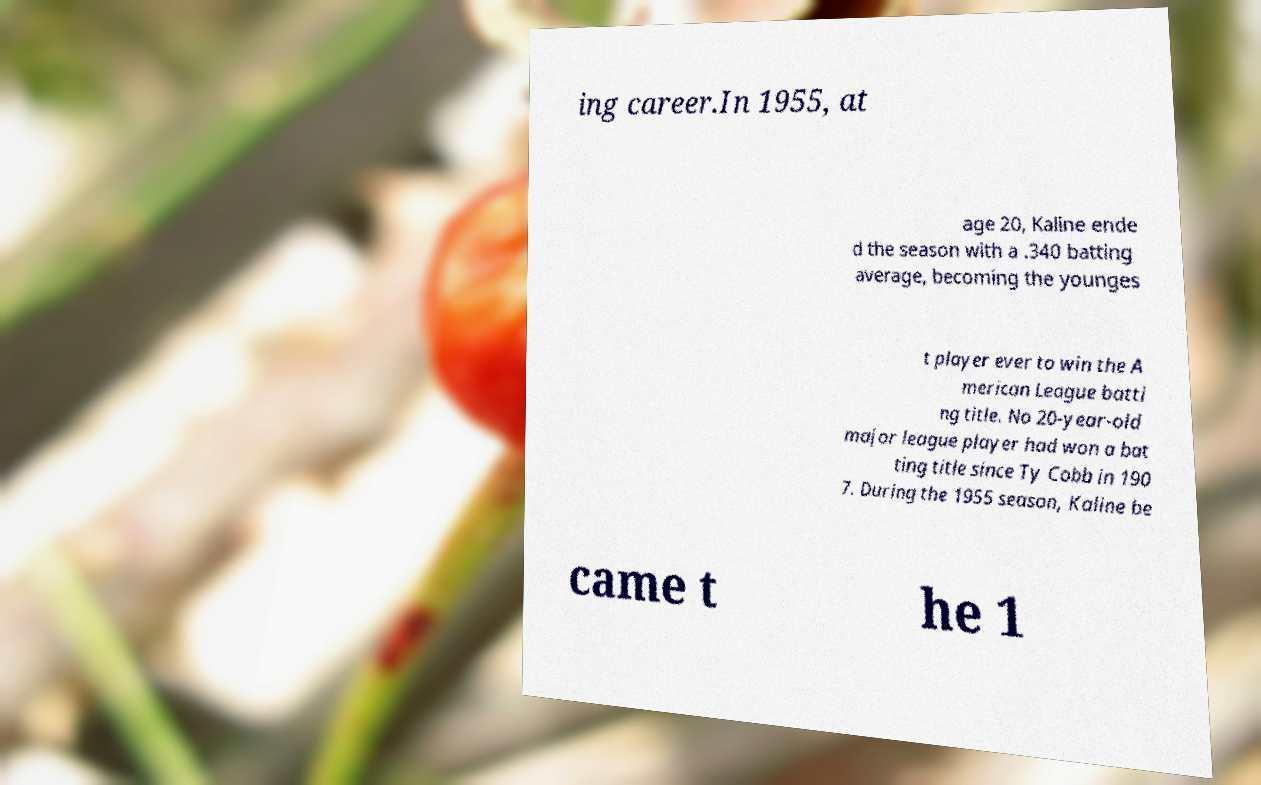Can you read and provide the text displayed in the image?This photo seems to have some interesting text. Can you extract and type it out for me? ing career.In 1955, at age 20, Kaline ende d the season with a .340 batting average, becoming the younges t player ever to win the A merican League batti ng title. No 20-year-old major league player had won a bat ting title since Ty Cobb in 190 7. During the 1955 season, Kaline be came t he 1 